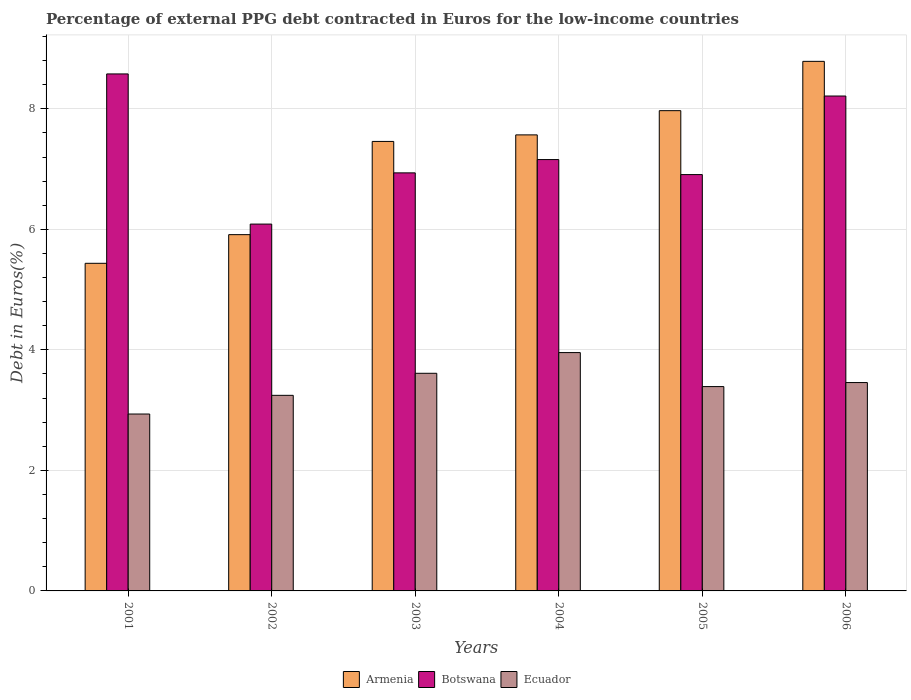How many different coloured bars are there?
Give a very brief answer. 3. How many bars are there on the 1st tick from the left?
Give a very brief answer. 3. How many bars are there on the 3rd tick from the right?
Provide a succinct answer. 3. In how many cases, is the number of bars for a given year not equal to the number of legend labels?
Ensure brevity in your answer.  0. What is the percentage of external PPG debt contracted in Euros in Armenia in 2006?
Ensure brevity in your answer.  8.79. Across all years, what is the maximum percentage of external PPG debt contracted in Euros in Botswana?
Provide a short and direct response. 8.58. Across all years, what is the minimum percentage of external PPG debt contracted in Euros in Ecuador?
Offer a terse response. 2.94. In which year was the percentage of external PPG debt contracted in Euros in Botswana minimum?
Give a very brief answer. 2002. What is the total percentage of external PPG debt contracted in Euros in Botswana in the graph?
Make the answer very short. 43.88. What is the difference between the percentage of external PPG debt contracted in Euros in Ecuador in 2001 and that in 2002?
Offer a very short reply. -0.31. What is the difference between the percentage of external PPG debt contracted in Euros in Botswana in 2005 and the percentage of external PPG debt contracted in Euros in Ecuador in 2001?
Your answer should be compact. 3.97. What is the average percentage of external PPG debt contracted in Euros in Armenia per year?
Provide a short and direct response. 7.19. In the year 2002, what is the difference between the percentage of external PPG debt contracted in Euros in Armenia and percentage of external PPG debt contracted in Euros in Ecuador?
Ensure brevity in your answer.  2.67. What is the ratio of the percentage of external PPG debt contracted in Euros in Botswana in 2002 to that in 2005?
Offer a terse response. 0.88. Is the percentage of external PPG debt contracted in Euros in Botswana in 2002 less than that in 2005?
Provide a succinct answer. Yes. What is the difference between the highest and the second highest percentage of external PPG debt contracted in Euros in Botswana?
Provide a succinct answer. 0.37. What is the difference between the highest and the lowest percentage of external PPG debt contracted in Euros in Ecuador?
Your answer should be compact. 1.02. Is the sum of the percentage of external PPG debt contracted in Euros in Botswana in 2003 and 2005 greater than the maximum percentage of external PPG debt contracted in Euros in Armenia across all years?
Ensure brevity in your answer.  Yes. What does the 3rd bar from the left in 2005 represents?
Ensure brevity in your answer.  Ecuador. What does the 1st bar from the right in 2002 represents?
Provide a succinct answer. Ecuador. Is it the case that in every year, the sum of the percentage of external PPG debt contracted in Euros in Botswana and percentage of external PPG debt contracted in Euros in Ecuador is greater than the percentage of external PPG debt contracted in Euros in Armenia?
Offer a terse response. Yes. Are all the bars in the graph horizontal?
Your response must be concise. No. How many years are there in the graph?
Make the answer very short. 6. Does the graph contain any zero values?
Provide a short and direct response. No. Where does the legend appear in the graph?
Offer a very short reply. Bottom center. What is the title of the graph?
Offer a very short reply. Percentage of external PPG debt contracted in Euros for the low-income countries. Does "Isle of Man" appear as one of the legend labels in the graph?
Provide a short and direct response. No. What is the label or title of the Y-axis?
Your response must be concise. Debt in Euros(%). What is the Debt in Euros(%) of Armenia in 2001?
Your answer should be very brief. 5.44. What is the Debt in Euros(%) of Botswana in 2001?
Provide a succinct answer. 8.58. What is the Debt in Euros(%) of Ecuador in 2001?
Offer a very short reply. 2.94. What is the Debt in Euros(%) in Armenia in 2002?
Your answer should be compact. 5.91. What is the Debt in Euros(%) of Botswana in 2002?
Give a very brief answer. 6.09. What is the Debt in Euros(%) of Ecuador in 2002?
Give a very brief answer. 3.25. What is the Debt in Euros(%) of Armenia in 2003?
Ensure brevity in your answer.  7.46. What is the Debt in Euros(%) in Botswana in 2003?
Keep it short and to the point. 6.94. What is the Debt in Euros(%) in Ecuador in 2003?
Make the answer very short. 3.61. What is the Debt in Euros(%) of Armenia in 2004?
Keep it short and to the point. 7.57. What is the Debt in Euros(%) of Botswana in 2004?
Keep it short and to the point. 7.16. What is the Debt in Euros(%) in Ecuador in 2004?
Ensure brevity in your answer.  3.96. What is the Debt in Euros(%) of Armenia in 2005?
Give a very brief answer. 7.97. What is the Debt in Euros(%) of Botswana in 2005?
Your answer should be compact. 6.91. What is the Debt in Euros(%) in Ecuador in 2005?
Offer a very short reply. 3.39. What is the Debt in Euros(%) in Armenia in 2006?
Ensure brevity in your answer.  8.79. What is the Debt in Euros(%) in Botswana in 2006?
Your response must be concise. 8.21. What is the Debt in Euros(%) in Ecuador in 2006?
Your answer should be very brief. 3.46. Across all years, what is the maximum Debt in Euros(%) of Armenia?
Your answer should be very brief. 8.79. Across all years, what is the maximum Debt in Euros(%) of Botswana?
Your answer should be very brief. 8.58. Across all years, what is the maximum Debt in Euros(%) of Ecuador?
Provide a short and direct response. 3.96. Across all years, what is the minimum Debt in Euros(%) in Armenia?
Give a very brief answer. 5.44. Across all years, what is the minimum Debt in Euros(%) of Botswana?
Your answer should be very brief. 6.09. Across all years, what is the minimum Debt in Euros(%) of Ecuador?
Give a very brief answer. 2.94. What is the total Debt in Euros(%) in Armenia in the graph?
Provide a succinct answer. 43.13. What is the total Debt in Euros(%) in Botswana in the graph?
Offer a terse response. 43.88. What is the total Debt in Euros(%) in Ecuador in the graph?
Your answer should be compact. 20.6. What is the difference between the Debt in Euros(%) in Armenia in 2001 and that in 2002?
Ensure brevity in your answer.  -0.48. What is the difference between the Debt in Euros(%) in Botswana in 2001 and that in 2002?
Ensure brevity in your answer.  2.49. What is the difference between the Debt in Euros(%) in Ecuador in 2001 and that in 2002?
Provide a succinct answer. -0.31. What is the difference between the Debt in Euros(%) of Armenia in 2001 and that in 2003?
Provide a short and direct response. -2.02. What is the difference between the Debt in Euros(%) of Botswana in 2001 and that in 2003?
Offer a very short reply. 1.64. What is the difference between the Debt in Euros(%) in Ecuador in 2001 and that in 2003?
Provide a short and direct response. -0.68. What is the difference between the Debt in Euros(%) in Armenia in 2001 and that in 2004?
Provide a succinct answer. -2.13. What is the difference between the Debt in Euros(%) in Botswana in 2001 and that in 2004?
Provide a short and direct response. 1.42. What is the difference between the Debt in Euros(%) of Ecuador in 2001 and that in 2004?
Give a very brief answer. -1.02. What is the difference between the Debt in Euros(%) of Armenia in 2001 and that in 2005?
Ensure brevity in your answer.  -2.53. What is the difference between the Debt in Euros(%) in Botswana in 2001 and that in 2005?
Give a very brief answer. 1.67. What is the difference between the Debt in Euros(%) of Ecuador in 2001 and that in 2005?
Ensure brevity in your answer.  -0.46. What is the difference between the Debt in Euros(%) of Armenia in 2001 and that in 2006?
Your answer should be very brief. -3.35. What is the difference between the Debt in Euros(%) of Botswana in 2001 and that in 2006?
Your answer should be compact. 0.37. What is the difference between the Debt in Euros(%) of Ecuador in 2001 and that in 2006?
Your answer should be very brief. -0.52. What is the difference between the Debt in Euros(%) of Armenia in 2002 and that in 2003?
Offer a very short reply. -1.55. What is the difference between the Debt in Euros(%) in Botswana in 2002 and that in 2003?
Give a very brief answer. -0.85. What is the difference between the Debt in Euros(%) in Ecuador in 2002 and that in 2003?
Provide a succinct answer. -0.37. What is the difference between the Debt in Euros(%) of Armenia in 2002 and that in 2004?
Provide a short and direct response. -1.66. What is the difference between the Debt in Euros(%) of Botswana in 2002 and that in 2004?
Your answer should be very brief. -1.07. What is the difference between the Debt in Euros(%) of Ecuador in 2002 and that in 2004?
Your answer should be compact. -0.71. What is the difference between the Debt in Euros(%) of Armenia in 2002 and that in 2005?
Give a very brief answer. -2.06. What is the difference between the Debt in Euros(%) of Botswana in 2002 and that in 2005?
Keep it short and to the point. -0.82. What is the difference between the Debt in Euros(%) in Ecuador in 2002 and that in 2005?
Give a very brief answer. -0.15. What is the difference between the Debt in Euros(%) in Armenia in 2002 and that in 2006?
Keep it short and to the point. -2.88. What is the difference between the Debt in Euros(%) of Botswana in 2002 and that in 2006?
Your answer should be compact. -2.13. What is the difference between the Debt in Euros(%) of Ecuador in 2002 and that in 2006?
Your answer should be very brief. -0.21. What is the difference between the Debt in Euros(%) in Armenia in 2003 and that in 2004?
Give a very brief answer. -0.11. What is the difference between the Debt in Euros(%) in Botswana in 2003 and that in 2004?
Give a very brief answer. -0.22. What is the difference between the Debt in Euros(%) in Ecuador in 2003 and that in 2004?
Offer a very short reply. -0.34. What is the difference between the Debt in Euros(%) of Armenia in 2003 and that in 2005?
Ensure brevity in your answer.  -0.51. What is the difference between the Debt in Euros(%) of Botswana in 2003 and that in 2005?
Your answer should be very brief. 0.03. What is the difference between the Debt in Euros(%) of Ecuador in 2003 and that in 2005?
Provide a succinct answer. 0.22. What is the difference between the Debt in Euros(%) in Armenia in 2003 and that in 2006?
Provide a short and direct response. -1.33. What is the difference between the Debt in Euros(%) of Botswana in 2003 and that in 2006?
Your answer should be very brief. -1.28. What is the difference between the Debt in Euros(%) in Ecuador in 2003 and that in 2006?
Provide a short and direct response. 0.15. What is the difference between the Debt in Euros(%) in Armenia in 2004 and that in 2005?
Give a very brief answer. -0.4. What is the difference between the Debt in Euros(%) in Botswana in 2004 and that in 2005?
Your answer should be compact. 0.25. What is the difference between the Debt in Euros(%) of Ecuador in 2004 and that in 2005?
Your response must be concise. 0.56. What is the difference between the Debt in Euros(%) of Armenia in 2004 and that in 2006?
Make the answer very short. -1.22. What is the difference between the Debt in Euros(%) in Botswana in 2004 and that in 2006?
Your response must be concise. -1.05. What is the difference between the Debt in Euros(%) in Ecuador in 2004 and that in 2006?
Your answer should be compact. 0.5. What is the difference between the Debt in Euros(%) of Armenia in 2005 and that in 2006?
Ensure brevity in your answer.  -0.82. What is the difference between the Debt in Euros(%) in Botswana in 2005 and that in 2006?
Offer a very short reply. -1.3. What is the difference between the Debt in Euros(%) of Ecuador in 2005 and that in 2006?
Keep it short and to the point. -0.07. What is the difference between the Debt in Euros(%) in Armenia in 2001 and the Debt in Euros(%) in Botswana in 2002?
Keep it short and to the point. -0.65. What is the difference between the Debt in Euros(%) in Armenia in 2001 and the Debt in Euros(%) in Ecuador in 2002?
Give a very brief answer. 2.19. What is the difference between the Debt in Euros(%) in Botswana in 2001 and the Debt in Euros(%) in Ecuador in 2002?
Provide a short and direct response. 5.33. What is the difference between the Debt in Euros(%) of Armenia in 2001 and the Debt in Euros(%) of Botswana in 2003?
Keep it short and to the point. -1.5. What is the difference between the Debt in Euros(%) of Armenia in 2001 and the Debt in Euros(%) of Ecuador in 2003?
Offer a terse response. 1.83. What is the difference between the Debt in Euros(%) of Botswana in 2001 and the Debt in Euros(%) of Ecuador in 2003?
Make the answer very short. 4.97. What is the difference between the Debt in Euros(%) in Armenia in 2001 and the Debt in Euros(%) in Botswana in 2004?
Offer a terse response. -1.72. What is the difference between the Debt in Euros(%) of Armenia in 2001 and the Debt in Euros(%) of Ecuador in 2004?
Provide a short and direct response. 1.48. What is the difference between the Debt in Euros(%) of Botswana in 2001 and the Debt in Euros(%) of Ecuador in 2004?
Ensure brevity in your answer.  4.62. What is the difference between the Debt in Euros(%) in Armenia in 2001 and the Debt in Euros(%) in Botswana in 2005?
Offer a very short reply. -1.47. What is the difference between the Debt in Euros(%) in Armenia in 2001 and the Debt in Euros(%) in Ecuador in 2005?
Ensure brevity in your answer.  2.05. What is the difference between the Debt in Euros(%) in Botswana in 2001 and the Debt in Euros(%) in Ecuador in 2005?
Offer a terse response. 5.19. What is the difference between the Debt in Euros(%) of Armenia in 2001 and the Debt in Euros(%) of Botswana in 2006?
Provide a short and direct response. -2.78. What is the difference between the Debt in Euros(%) of Armenia in 2001 and the Debt in Euros(%) of Ecuador in 2006?
Your answer should be compact. 1.98. What is the difference between the Debt in Euros(%) in Botswana in 2001 and the Debt in Euros(%) in Ecuador in 2006?
Your answer should be compact. 5.12. What is the difference between the Debt in Euros(%) in Armenia in 2002 and the Debt in Euros(%) in Botswana in 2003?
Keep it short and to the point. -1.03. What is the difference between the Debt in Euros(%) of Armenia in 2002 and the Debt in Euros(%) of Ecuador in 2003?
Your response must be concise. 2.3. What is the difference between the Debt in Euros(%) of Botswana in 2002 and the Debt in Euros(%) of Ecuador in 2003?
Your answer should be very brief. 2.48. What is the difference between the Debt in Euros(%) in Armenia in 2002 and the Debt in Euros(%) in Botswana in 2004?
Keep it short and to the point. -1.25. What is the difference between the Debt in Euros(%) in Armenia in 2002 and the Debt in Euros(%) in Ecuador in 2004?
Make the answer very short. 1.96. What is the difference between the Debt in Euros(%) in Botswana in 2002 and the Debt in Euros(%) in Ecuador in 2004?
Give a very brief answer. 2.13. What is the difference between the Debt in Euros(%) in Armenia in 2002 and the Debt in Euros(%) in Botswana in 2005?
Provide a succinct answer. -1. What is the difference between the Debt in Euros(%) of Armenia in 2002 and the Debt in Euros(%) of Ecuador in 2005?
Ensure brevity in your answer.  2.52. What is the difference between the Debt in Euros(%) in Botswana in 2002 and the Debt in Euros(%) in Ecuador in 2005?
Keep it short and to the point. 2.7. What is the difference between the Debt in Euros(%) of Armenia in 2002 and the Debt in Euros(%) of Botswana in 2006?
Provide a short and direct response. -2.3. What is the difference between the Debt in Euros(%) of Armenia in 2002 and the Debt in Euros(%) of Ecuador in 2006?
Ensure brevity in your answer.  2.45. What is the difference between the Debt in Euros(%) of Botswana in 2002 and the Debt in Euros(%) of Ecuador in 2006?
Offer a terse response. 2.63. What is the difference between the Debt in Euros(%) in Armenia in 2003 and the Debt in Euros(%) in Botswana in 2004?
Your answer should be compact. 0.3. What is the difference between the Debt in Euros(%) of Armenia in 2003 and the Debt in Euros(%) of Ecuador in 2004?
Provide a succinct answer. 3.5. What is the difference between the Debt in Euros(%) in Botswana in 2003 and the Debt in Euros(%) in Ecuador in 2004?
Your answer should be very brief. 2.98. What is the difference between the Debt in Euros(%) in Armenia in 2003 and the Debt in Euros(%) in Botswana in 2005?
Ensure brevity in your answer.  0.55. What is the difference between the Debt in Euros(%) in Armenia in 2003 and the Debt in Euros(%) in Ecuador in 2005?
Your response must be concise. 4.07. What is the difference between the Debt in Euros(%) of Botswana in 2003 and the Debt in Euros(%) of Ecuador in 2005?
Make the answer very short. 3.55. What is the difference between the Debt in Euros(%) in Armenia in 2003 and the Debt in Euros(%) in Botswana in 2006?
Provide a short and direct response. -0.75. What is the difference between the Debt in Euros(%) in Armenia in 2003 and the Debt in Euros(%) in Ecuador in 2006?
Your answer should be very brief. 4. What is the difference between the Debt in Euros(%) in Botswana in 2003 and the Debt in Euros(%) in Ecuador in 2006?
Provide a short and direct response. 3.48. What is the difference between the Debt in Euros(%) in Armenia in 2004 and the Debt in Euros(%) in Botswana in 2005?
Keep it short and to the point. 0.66. What is the difference between the Debt in Euros(%) of Armenia in 2004 and the Debt in Euros(%) of Ecuador in 2005?
Provide a short and direct response. 4.18. What is the difference between the Debt in Euros(%) in Botswana in 2004 and the Debt in Euros(%) in Ecuador in 2005?
Your answer should be compact. 3.77. What is the difference between the Debt in Euros(%) of Armenia in 2004 and the Debt in Euros(%) of Botswana in 2006?
Offer a very short reply. -0.64. What is the difference between the Debt in Euros(%) in Armenia in 2004 and the Debt in Euros(%) in Ecuador in 2006?
Your response must be concise. 4.11. What is the difference between the Debt in Euros(%) in Botswana in 2004 and the Debt in Euros(%) in Ecuador in 2006?
Ensure brevity in your answer.  3.7. What is the difference between the Debt in Euros(%) of Armenia in 2005 and the Debt in Euros(%) of Botswana in 2006?
Your answer should be very brief. -0.24. What is the difference between the Debt in Euros(%) in Armenia in 2005 and the Debt in Euros(%) in Ecuador in 2006?
Provide a short and direct response. 4.51. What is the difference between the Debt in Euros(%) of Botswana in 2005 and the Debt in Euros(%) of Ecuador in 2006?
Offer a terse response. 3.45. What is the average Debt in Euros(%) in Armenia per year?
Keep it short and to the point. 7.19. What is the average Debt in Euros(%) of Botswana per year?
Keep it short and to the point. 7.31. What is the average Debt in Euros(%) in Ecuador per year?
Make the answer very short. 3.43. In the year 2001, what is the difference between the Debt in Euros(%) of Armenia and Debt in Euros(%) of Botswana?
Keep it short and to the point. -3.14. In the year 2001, what is the difference between the Debt in Euros(%) of Armenia and Debt in Euros(%) of Ecuador?
Your answer should be compact. 2.5. In the year 2001, what is the difference between the Debt in Euros(%) in Botswana and Debt in Euros(%) in Ecuador?
Ensure brevity in your answer.  5.64. In the year 2002, what is the difference between the Debt in Euros(%) of Armenia and Debt in Euros(%) of Botswana?
Keep it short and to the point. -0.18. In the year 2002, what is the difference between the Debt in Euros(%) of Armenia and Debt in Euros(%) of Ecuador?
Your answer should be very brief. 2.67. In the year 2002, what is the difference between the Debt in Euros(%) of Botswana and Debt in Euros(%) of Ecuador?
Give a very brief answer. 2.84. In the year 2003, what is the difference between the Debt in Euros(%) in Armenia and Debt in Euros(%) in Botswana?
Your answer should be compact. 0.52. In the year 2003, what is the difference between the Debt in Euros(%) in Armenia and Debt in Euros(%) in Ecuador?
Provide a succinct answer. 3.85. In the year 2003, what is the difference between the Debt in Euros(%) in Botswana and Debt in Euros(%) in Ecuador?
Your answer should be compact. 3.33. In the year 2004, what is the difference between the Debt in Euros(%) in Armenia and Debt in Euros(%) in Botswana?
Provide a succinct answer. 0.41. In the year 2004, what is the difference between the Debt in Euros(%) of Armenia and Debt in Euros(%) of Ecuador?
Provide a succinct answer. 3.61. In the year 2004, what is the difference between the Debt in Euros(%) of Botswana and Debt in Euros(%) of Ecuador?
Ensure brevity in your answer.  3.2. In the year 2005, what is the difference between the Debt in Euros(%) of Armenia and Debt in Euros(%) of Botswana?
Offer a terse response. 1.06. In the year 2005, what is the difference between the Debt in Euros(%) of Armenia and Debt in Euros(%) of Ecuador?
Provide a succinct answer. 4.58. In the year 2005, what is the difference between the Debt in Euros(%) in Botswana and Debt in Euros(%) in Ecuador?
Your answer should be very brief. 3.52. In the year 2006, what is the difference between the Debt in Euros(%) in Armenia and Debt in Euros(%) in Botswana?
Provide a short and direct response. 0.58. In the year 2006, what is the difference between the Debt in Euros(%) of Armenia and Debt in Euros(%) of Ecuador?
Make the answer very short. 5.33. In the year 2006, what is the difference between the Debt in Euros(%) in Botswana and Debt in Euros(%) in Ecuador?
Keep it short and to the point. 4.75. What is the ratio of the Debt in Euros(%) in Armenia in 2001 to that in 2002?
Provide a short and direct response. 0.92. What is the ratio of the Debt in Euros(%) of Botswana in 2001 to that in 2002?
Offer a very short reply. 1.41. What is the ratio of the Debt in Euros(%) of Ecuador in 2001 to that in 2002?
Give a very brief answer. 0.9. What is the ratio of the Debt in Euros(%) of Armenia in 2001 to that in 2003?
Give a very brief answer. 0.73. What is the ratio of the Debt in Euros(%) in Botswana in 2001 to that in 2003?
Your response must be concise. 1.24. What is the ratio of the Debt in Euros(%) in Ecuador in 2001 to that in 2003?
Give a very brief answer. 0.81. What is the ratio of the Debt in Euros(%) of Armenia in 2001 to that in 2004?
Make the answer very short. 0.72. What is the ratio of the Debt in Euros(%) of Botswana in 2001 to that in 2004?
Keep it short and to the point. 1.2. What is the ratio of the Debt in Euros(%) in Ecuador in 2001 to that in 2004?
Provide a succinct answer. 0.74. What is the ratio of the Debt in Euros(%) of Armenia in 2001 to that in 2005?
Your answer should be compact. 0.68. What is the ratio of the Debt in Euros(%) in Botswana in 2001 to that in 2005?
Ensure brevity in your answer.  1.24. What is the ratio of the Debt in Euros(%) of Ecuador in 2001 to that in 2005?
Your answer should be very brief. 0.87. What is the ratio of the Debt in Euros(%) of Armenia in 2001 to that in 2006?
Provide a short and direct response. 0.62. What is the ratio of the Debt in Euros(%) of Botswana in 2001 to that in 2006?
Provide a succinct answer. 1.04. What is the ratio of the Debt in Euros(%) of Ecuador in 2001 to that in 2006?
Your response must be concise. 0.85. What is the ratio of the Debt in Euros(%) of Armenia in 2002 to that in 2003?
Provide a succinct answer. 0.79. What is the ratio of the Debt in Euros(%) in Botswana in 2002 to that in 2003?
Your response must be concise. 0.88. What is the ratio of the Debt in Euros(%) of Ecuador in 2002 to that in 2003?
Offer a very short reply. 0.9. What is the ratio of the Debt in Euros(%) of Armenia in 2002 to that in 2004?
Offer a very short reply. 0.78. What is the ratio of the Debt in Euros(%) of Botswana in 2002 to that in 2004?
Your answer should be compact. 0.85. What is the ratio of the Debt in Euros(%) in Ecuador in 2002 to that in 2004?
Offer a very short reply. 0.82. What is the ratio of the Debt in Euros(%) of Armenia in 2002 to that in 2005?
Provide a succinct answer. 0.74. What is the ratio of the Debt in Euros(%) of Botswana in 2002 to that in 2005?
Provide a short and direct response. 0.88. What is the ratio of the Debt in Euros(%) in Ecuador in 2002 to that in 2005?
Your response must be concise. 0.96. What is the ratio of the Debt in Euros(%) in Armenia in 2002 to that in 2006?
Provide a short and direct response. 0.67. What is the ratio of the Debt in Euros(%) of Botswana in 2002 to that in 2006?
Make the answer very short. 0.74. What is the ratio of the Debt in Euros(%) of Ecuador in 2002 to that in 2006?
Keep it short and to the point. 0.94. What is the ratio of the Debt in Euros(%) in Armenia in 2003 to that in 2004?
Your answer should be compact. 0.99. What is the ratio of the Debt in Euros(%) in Botswana in 2003 to that in 2004?
Provide a succinct answer. 0.97. What is the ratio of the Debt in Euros(%) of Ecuador in 2003 to that in 2004?
Keep it short and to the point. 0.91. What is the ratio of the Debt in Euros(%) in Armenia in 2003 to that in 2005?
Your response must be concise. 0.94. What is the ratio of the Debt in Euros(%) in Ecuador in 2003 to that in 2005?
Your answer should be compact. 1.06. What is the ratio of the Debt in Euros(%) of Armenia in 2003 to that in 2006?
Your response must be concise. 0.85. What is the ratio of the Debt in Euros(%) in Botswana in 2003 to that in 2006?
Your response must be concise. 0.84. What is the ratio of the Debt in Euros(%) in Ecuador in 2003 to that in 2006?
Your response must be concise. 1.04. What is the ratio of the Debt in Euros(%) of Armenia in 2004 to that in 2005?
Your answer should be very brief. 0.95. What is the ratio of the Debt in Euros(%) of Botswana in 2004 to that in 2005?
Make the answer very short. 1.04. What is the ratio of the Debt in Euros(%) in Ecuador in 2004 to that in 2005?
Your response must be concise. 1.17. What is the ratio of the Debt in Euros(%) of Armenia in 2004 to that in 2006?
Your answer should be compact. 0.86. What is the ratio of the Debt in Euros(%) of Botswana in 2004 to that in 2006?
Provide a succinct answer. 0.87. What is the ratio of the Debt in Euros(%) in Ecuador in 2004 to that in 2006?
Your response must be concise. 1.14. What is the ratio of the Debt in Euros(%) in Armenia in 2005 to that in 2006?
Your response must be concise. 0.91. What is the ratio of the Debt in Euros(%) in Botswana in 2005 to that in 2006?
Give a very brief answer. 0.84. What is the ratio of the Debt in Euros(%) of Ecuador in 2005 to that in 2006?
Offer a very short reply. 0.98. What is the difference between the highest and the second highest Debt in Euros(%) in Armenia?
Give a very brief answer. 0.82. What is the difference between the highest and the second highest Debt in Euros(%) in Botswana?
Keep it short and to the point. 0.37. What is the difference between the highest and the second highest Debt in Euros(%) of Ecuador?
Your response must be concise. 0.34. What is the difference between the highest and the lowest Debt in Euros(%) of Armenia?
Ensure brevity in your answer.  3.35. What is the difference between the highest and the lowest Debt in Euros(%) in Botswana?
Ensure brevity in your answer.  2.49. What is the difference between the highest and the lowest Debt in Euros(%) of Ecuador?
Keep it short and to the point. 1.02. 